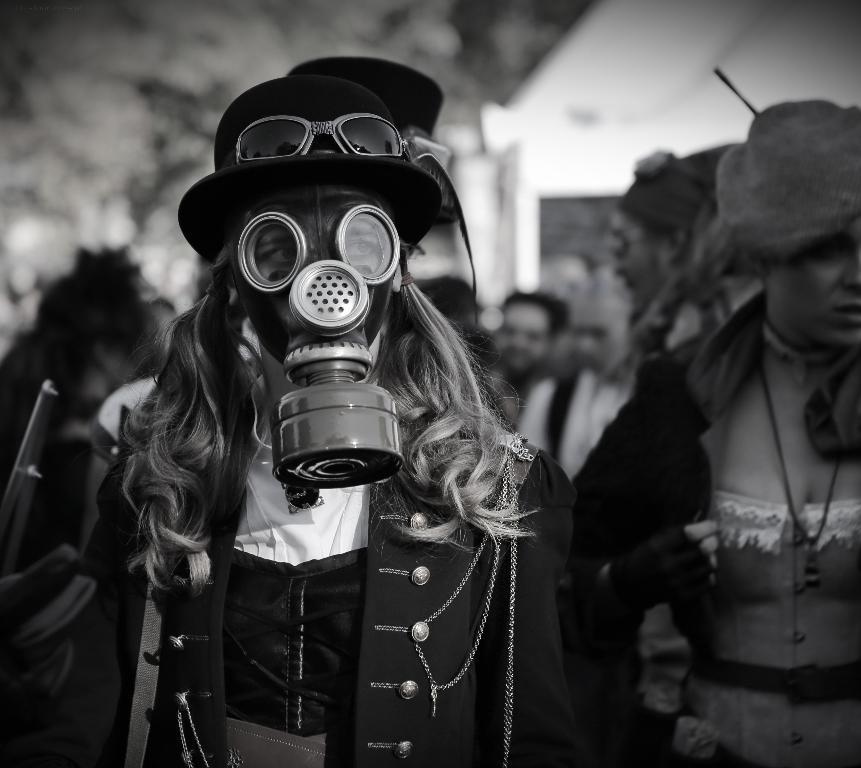In one or two sentences, can you explain what this image depicts? In this picture we can see some people standing here, a person in the front wore a mask, we can see a blurry background. 